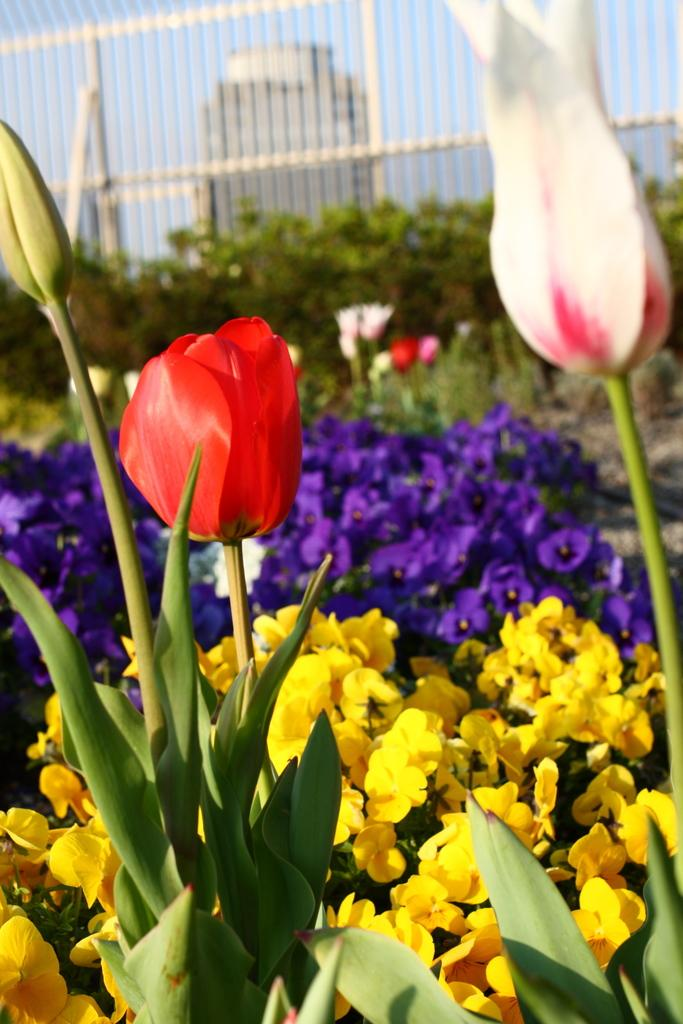What types of vegetation can be seen in the image? There are plants and flowers in the image. What distinguishes the plants and flowers from each other? The plants and flowers have different colors. What other natural elements are present in the image? There are trees in the image. What man-made structure can be seen in the image? There is a fence in the image. How would you describe the overall appearance of the image? The background of the image is blurred. What type of coal is being used to fuel the plants in the image? There is no coal present in the image, and plants do not require coal for fuel. Can you see any masks being worn by the plants in the image? There are no masks or people present in the image, only plants and flowers. 